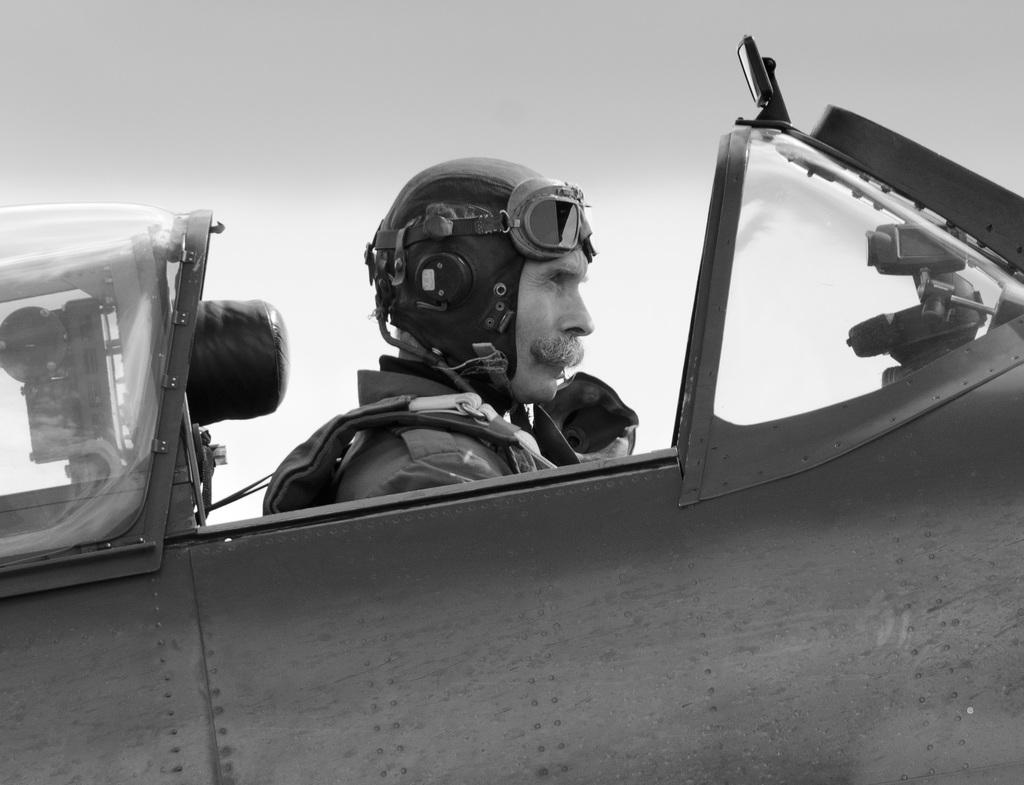What is the person in the image doing? The person is sitting inside a vehicle in the image. What protective gear is the person wearing? The person is wearing a helmet. What is the color scheme of the image? The image is in black and white. What type of glass is being used to play basketball in the image? There is no glass or basketball present in the image. 